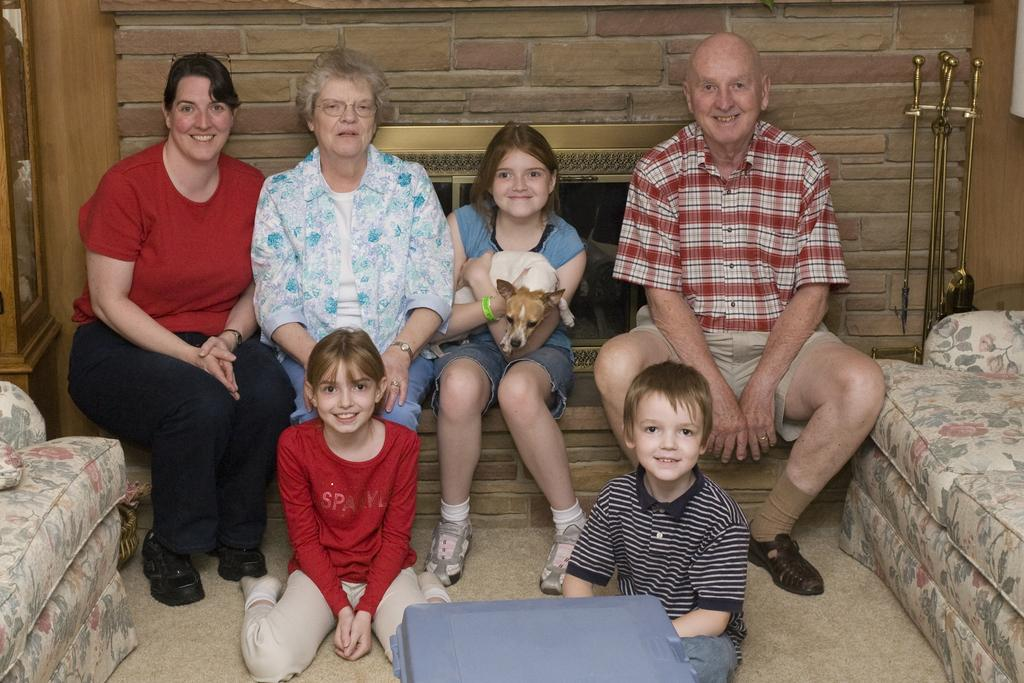Who can be seen in the image? There are people in the image, including women, children, and a man. What type of animal is present in the image? A dog is present in the image. Can you describe the background of the image? There is a wall in the background of the image. What type of leather can be seen on the crate in the image? There is no crate or leather present in the image. What type of hydrant is visible in the image? There is no hydrant present in the image. 